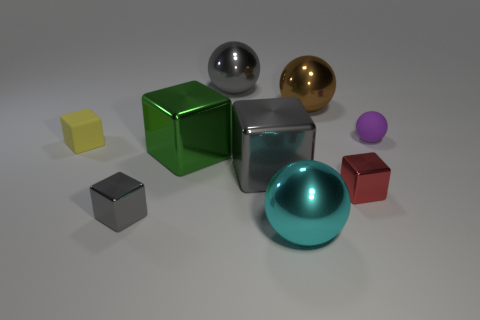The matte block is what color?
Your response must be concise. Yellow. There is a big brown object that is made of the same material as the green object; what shape is it?
Make the answer very short. Sphere. Is the size of the sphere on the left side of the cyan metal ball the same as the cyan thing?
Your answer should be compact. Yes. What number of things are either small objects that are to the right of the tiny yellow rubber object or big shiny balls that are behind the red shiny cube?
Offer a terse response. 5. What number of shiny things are big purple objects or yellow objects?
Make the answer very short. 0. The big green thing has what shape?
Your answer should be compact. Cube. Are the cyan thing and the big green thing made of the same material?
Give a very brief answer. Yes. Is there a tiny rubber thing that is in front of the gray shiny block that is behind the small block to the right of the large gray ball?
Offer a very short reply. No. How many other things are the same shape as the large green thing?
Offer a terse response. 4. There is a gray shiny object that is both in front of the large green object and right of the green block; what is its shape?
Provide a short and direct response. Cube. 